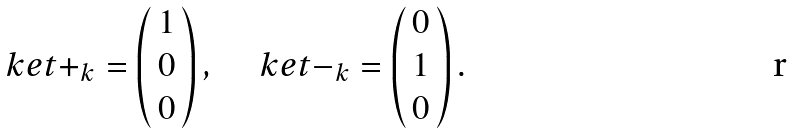Convert formula to latex. <formula><loc_0><loc_0><loc_500><loc_500>\ k e t { + } _ { k } = \begin{pmatrix} 1 \\ 0 \\ \, 0 \, \\ \end{pmatrix} , \quad \ k e t { - } _ { k } = \begin{pmatrix} 0 \\ 1 \\ \, 0 \, \\ \end{pmatrix} .</formula> 